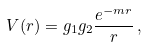Convert formula to latex. <formula><loc_0><loc_0><loc_500><loc_500>V ( r ) = g _ { 1 } g _ { 2 } \frac { e ^ { - m r } } { r } \, ,</formula> 